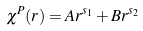<formula> <loc_0><loc_0><loc_500><loc_500>\chi ^ { P } ( r ) = A r ^ { s _ { 1 } } + B r ^ { s _ { 2 } }</formula> 